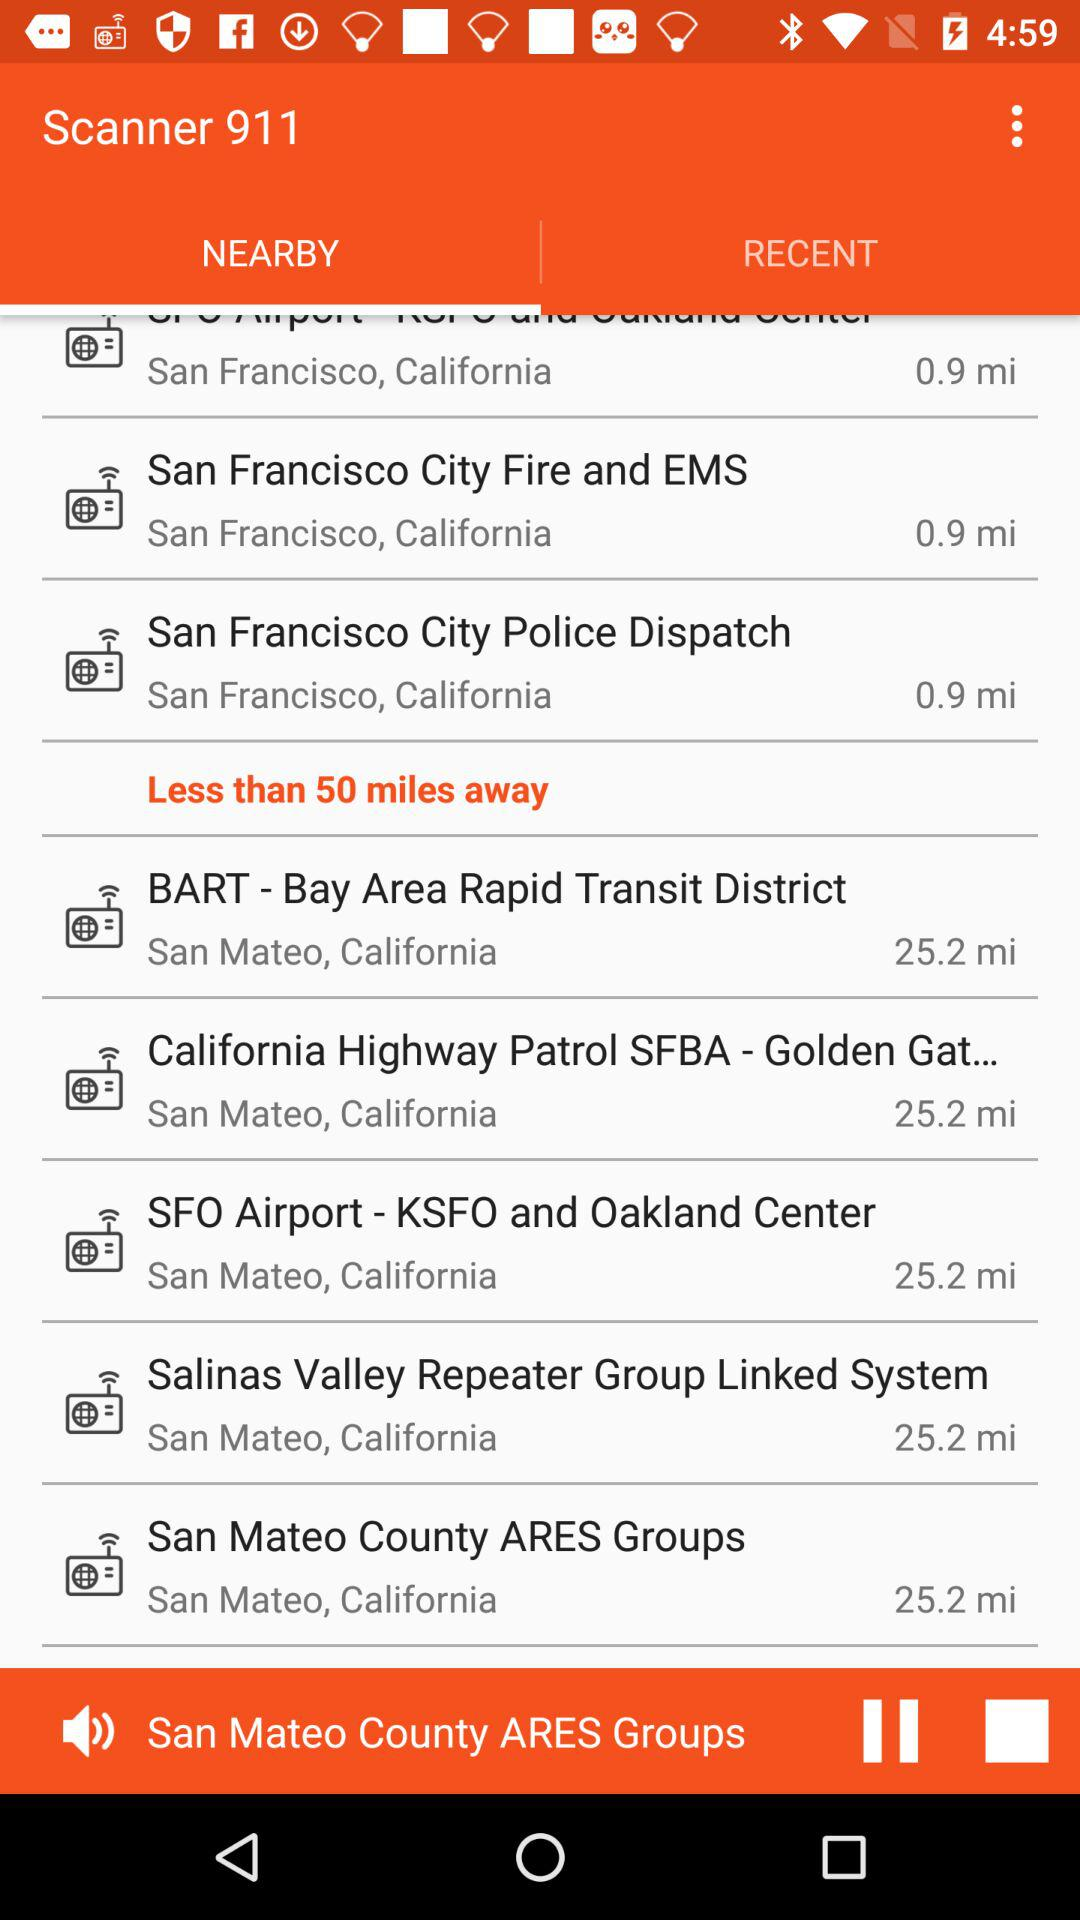How far is the San Francisco City Police Dispatch? The San Francisco City Police Dispatch is 0.9 miles away. 